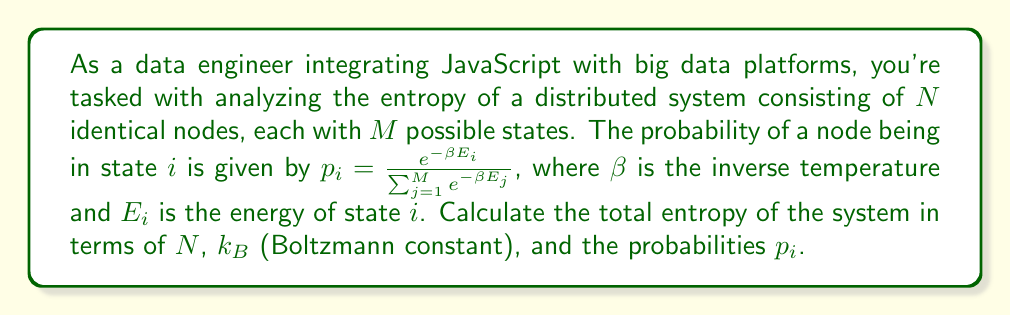Solve this math problem. To determine the entropy of this large-scale distributed system, we'll use principles from statistical mechanics:

1) The entropy of a single node is given by the Gibbs entropy formula:
   $$S_1 = -k_B \sum_{i=1}^M p_i \ln p_i$$

2) Since the system consists of $N$ identical and independent nodes, the total entropy is $N$ times the entropy of a single node:
   $$S_{total} = N S_1 = -N k_B \sum_{i=1}^M p_i \ln p_i$$

3) We can expand this equation:
   $$S_{total} = -N k_B (p_1 \ln p_1 + p_2 \ln p_2 + ... + p_M \ln p_M)$$

4) The probabilities $p_i$ sum to 1:
   $$\sum_{i=1}^M p_i = 1$$

5) This formula gives us the entropy of the entire distributed system in terms of $N$, $k_B$, and the probabilities $p_i$ of each state.

In a JavaScript implementation, you would calculate this by iterating over all states, computing each $p_i \ln p_i$ term, summing them, and then multiplying by $-N k_B$.
Answer: $$S_{total} = -N k_B \sum_{i=1}^M p_i \ln p_i$$ 